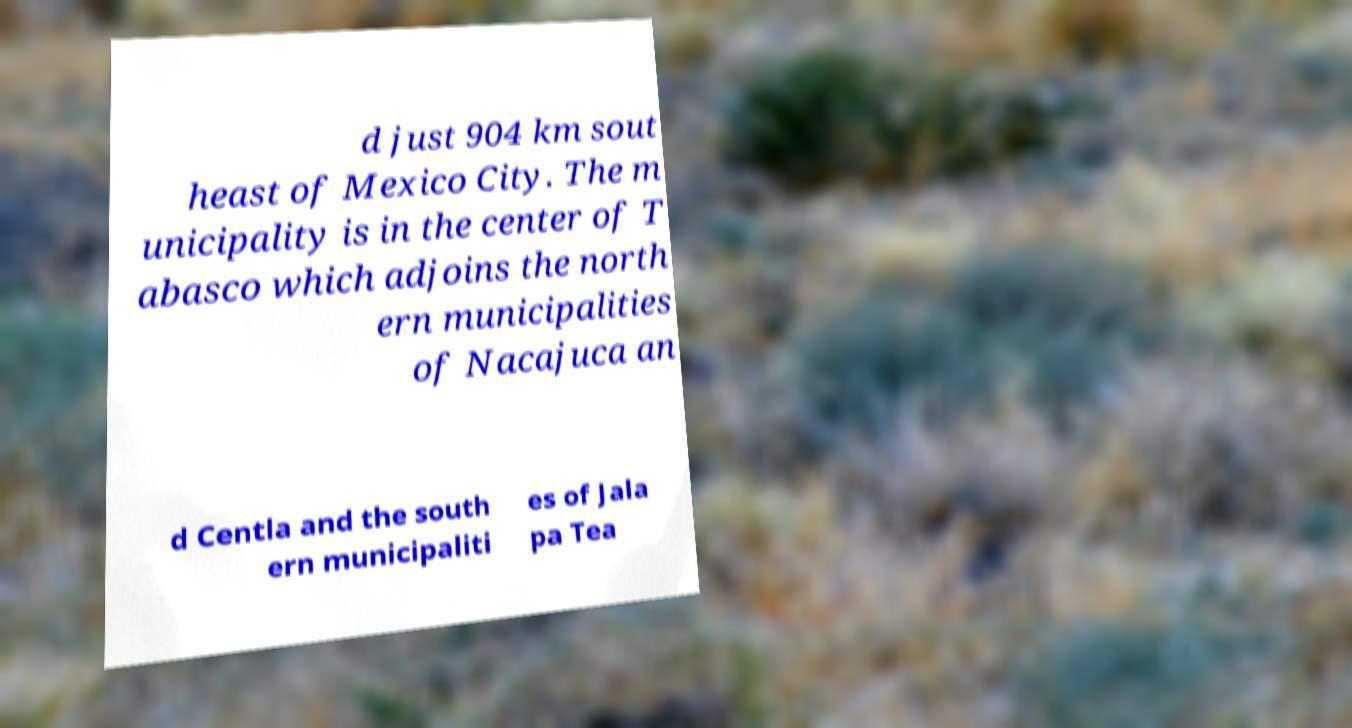Please read and relay the text visible in this image. What does it say? d just 904 km sout heast of Mexico City. The m unicipality is in the center of T abasco which adjoins the north ern municipalities of Nacajuca an d Centla and the south ern municipaliti es of Jala pa Tea 